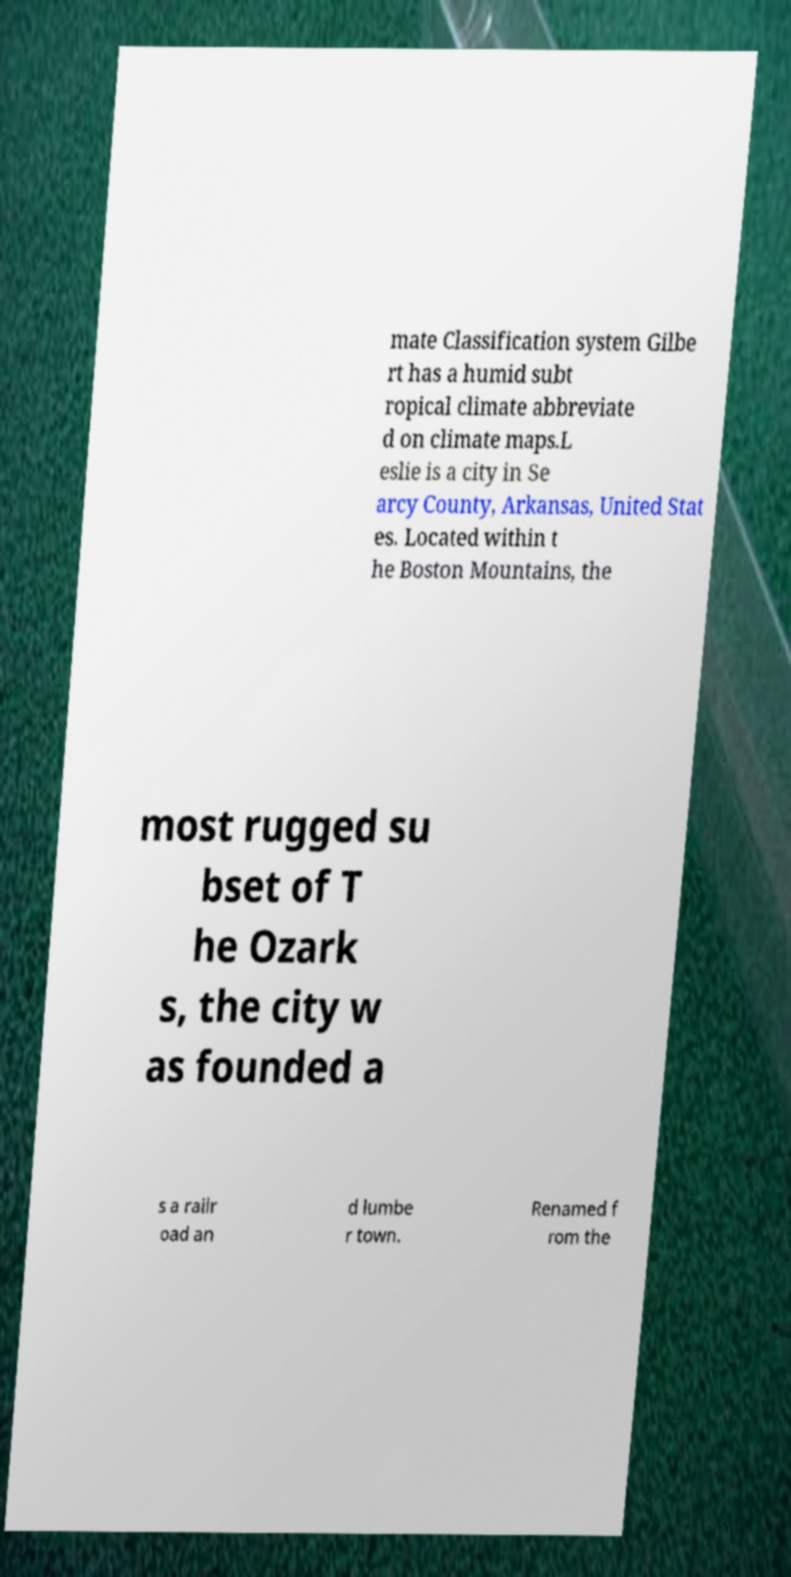Please identify and transcribe the text found in this image. mate Classification system Gilbe rt has a humid subt ropical climate abbreviate d on climate maps.L eslie is a city in Se arcy County, Arkansas, United Stat es. Located within t he Boston Mountains, the most rugged su bset of T he Ozark s, the city w as founded a s a railr oad an d lumbe r town. Renamed f rom the 